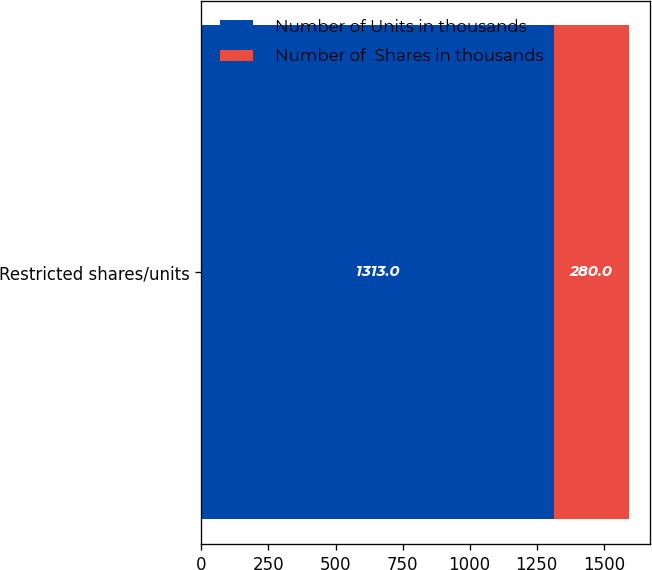Convert chart to OTSL. <chart><loc_0><loc_0><loc_500><loc_500><stacked_bar_chart><ecel><fcel>Restricted shares/units<nl><fcel>Number of Units in thousands<fcel>1313<nl><fcel>Number of  Shares in thousands<fcel>280<nl></chart> 